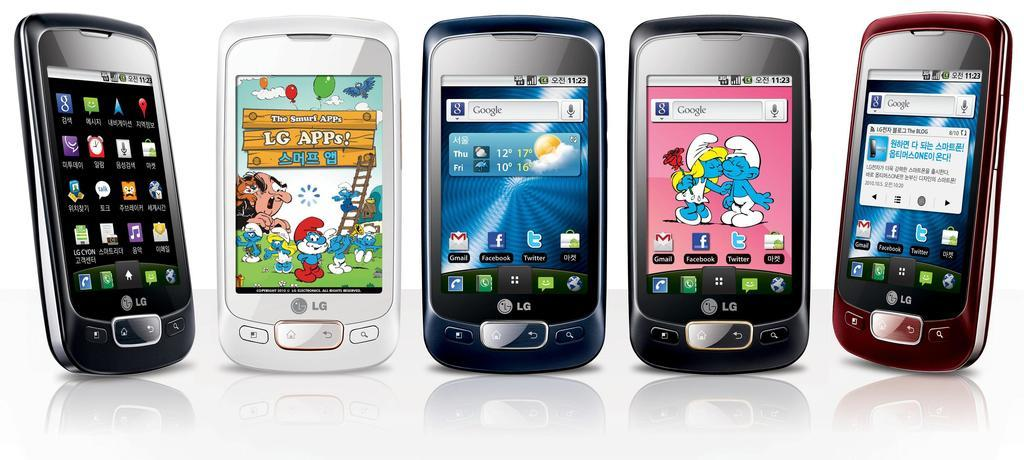<image>
Give a short and clear explanation of the subsequent image. Multiple mobile devices near each other at 11:23. 